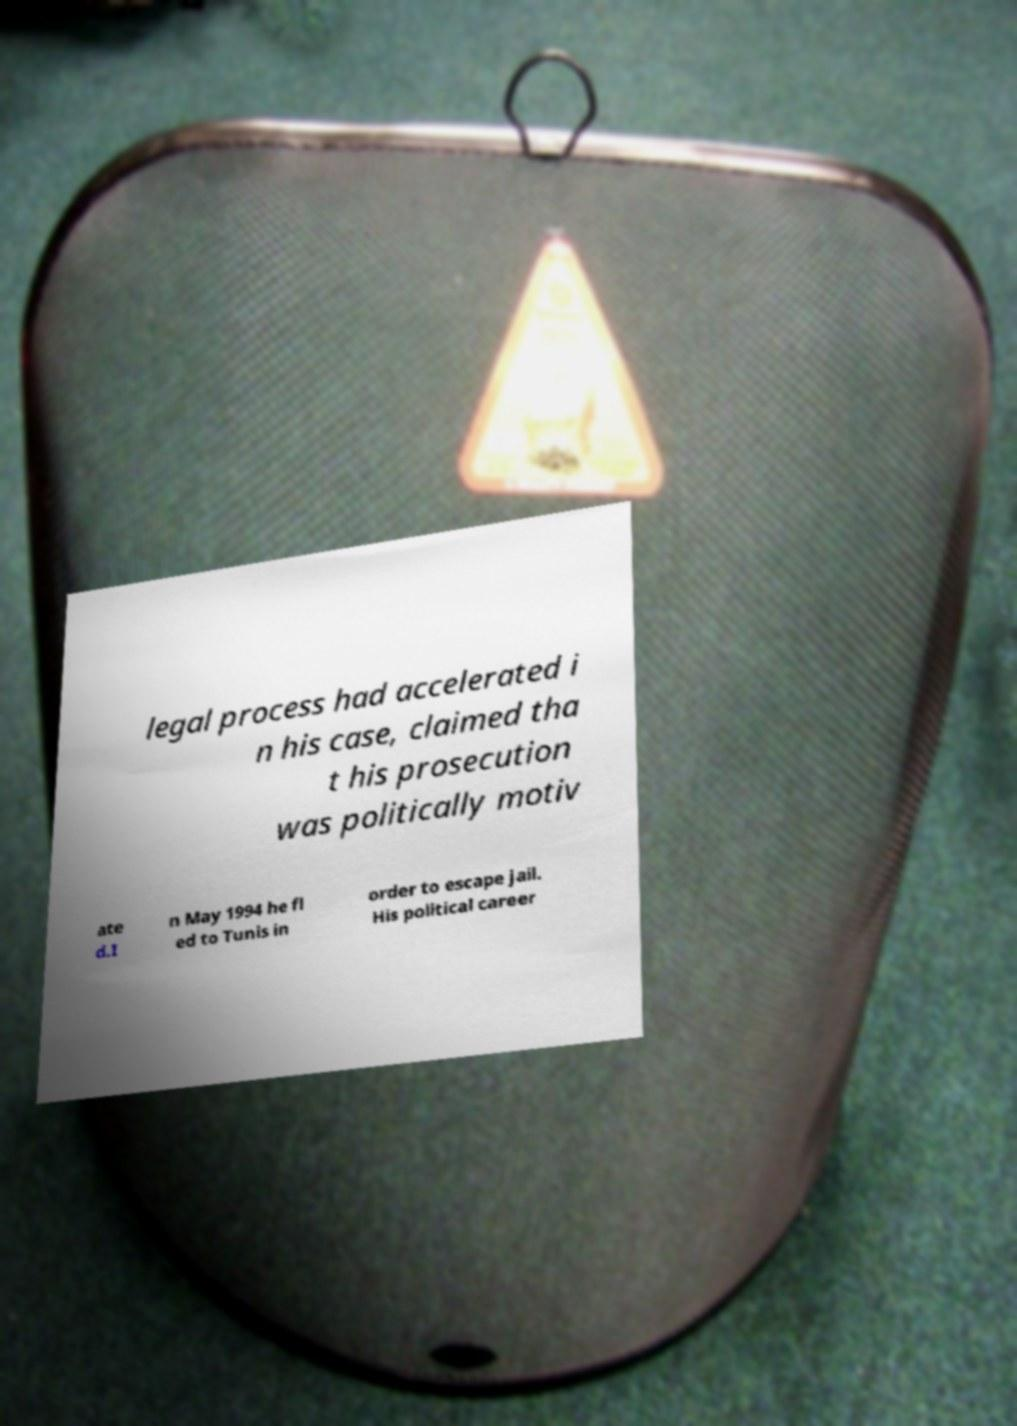What messages or text are displayed in this image? I need them in a readable, typed format. legal process had accelerated i n his case, claimed tha t his prosecution was politically motiv ate d.I n May 1994 he fl ed to Tunis in order to escape jail. His political career 